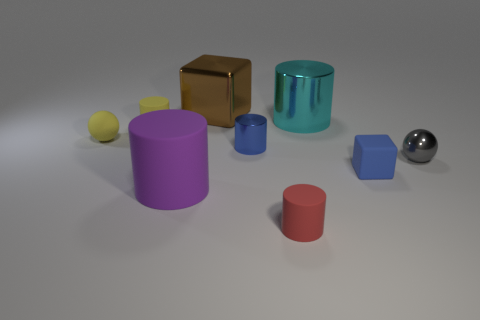Subtract all tiny matte cylinders. How many cylinders are left? 3 Subtract 1 cubes. How many cubes are left? 1 Subtract all spheres. How many objects are left? 7 Subtract all yellow spheres. How many spheres are left? 1 Add 6 brown rubber things. How many brown rubber things exist? 6 Subtract 0 blue spheres. How many objects are left? 9 Subtract all green cylinders. Subtract all brown balls. How many cylinders are left? 5 Subtract all large cyan things. Subtract all gray spheres. How many objects are left? 7 Add 8 shiny cylinders. How many shiny cylinders are left? 10 